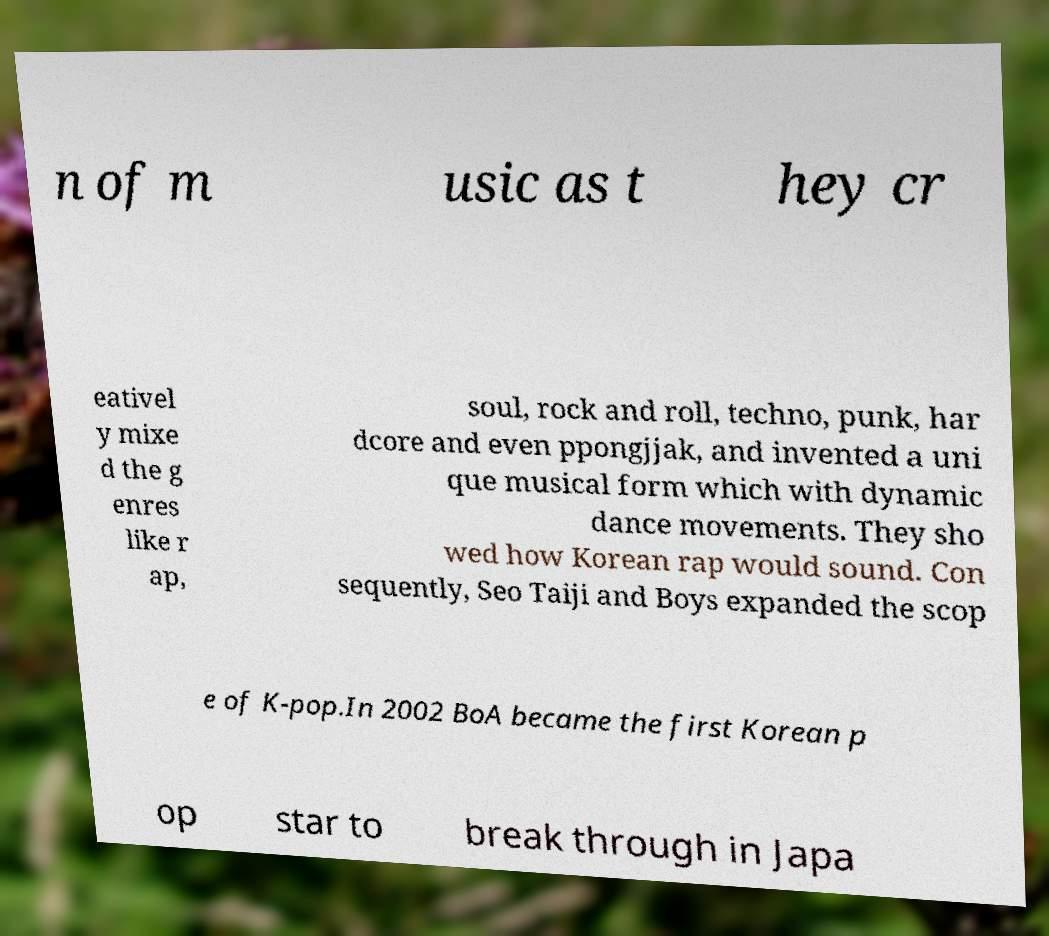Could you assist in decoding the text presented in this image and type it out clearly? n of m usic as t hey cr eativel y mixe d the g enres like r ap, soul, rock and roll, techno, punk, har dcore and even ppongjjak, and invented a uni que musical form which with dynamic dance movements. They sho wed how Korean rap would sound. Con sequently, Seo Taiji and Boys expanded the scop e of K-pop.In 2002 BoA became the first Korean p op star to break through in Japa 